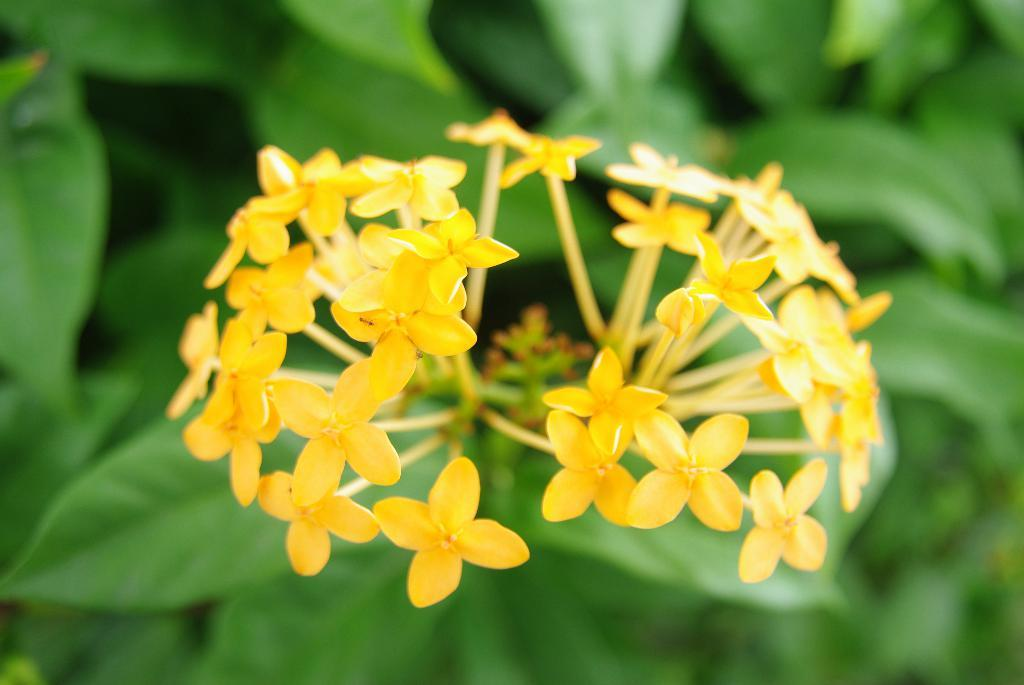What type of flowers can be seen on the plant in the image? There are yellow flowers on a plant in the image. What color are the leaves on the left side of the image? There are green leaves on the left side of the image. What does the hall smell like in the image? There is no mention of a hall or any smell in the image; it only features yellow flowers and green leaves. 